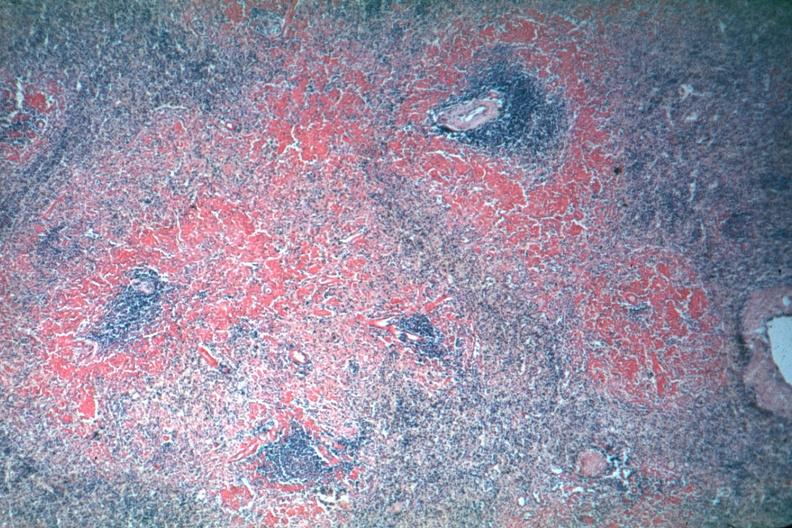what does this image show?
Answer the question using a single word or phrase. Not sure of stain may be sirus red perifollicular amyloid deposits are well shown though exposure is not the best 